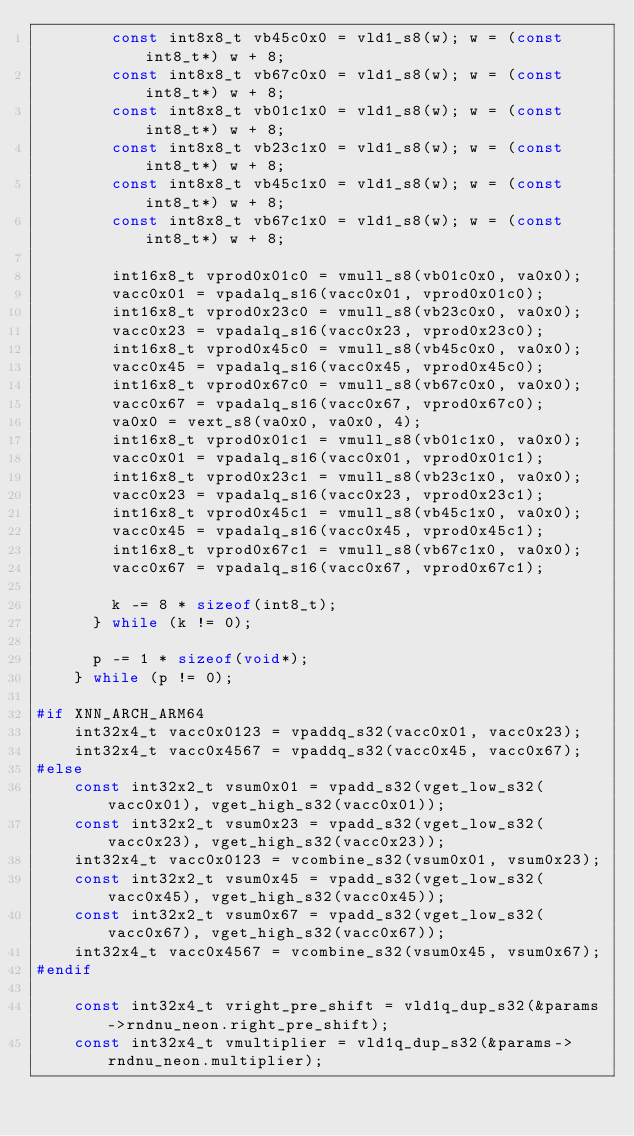<code> <loc_0><loc_0><loc_500><loc_500><_C_>        const int8x8_t vb45c0x0 = vld1_s8(w); w = (const int8_t*) w + 8;
        const int8x8_t vb67c0x0 = vld1_s8(w); w = (const int8_t*) w + 8;
        const int8x8_t vb01c1x0 = vld1_s8(w); w = (const int8_t*) w + 8;
        const int8x8_t vb23c1x0 = vld1_s8(w); w = (const int8_t*) w + 8;
        const int8x8_t vb45c1x0 = vld1_s8(w); w = (const int8_t*) w + 8;
        const int8x8_t vb67c1x0 = vld1_s8(w); w = (const int8_t*) w + 8;

        int16x8_t vprod0x01c0 = vmull_s8(vb01c0x0, va0x0);
        vacc0x01 = vpadalq_s16(vacc0x01, vprod0x01c0);
        int16x8_t vprod0x23c0 = vmull_s8(vb23c0x0, va0x0);
        vacc0x23 = vpadalq_s16(vacc0x23, vprod0x23c0);
        int16x8_t vprod0x45c0 = vmull_s8(vb45c0x0, va0x0);
        vacc0x45 = vpadalq_s16(vacc0x45, vprod0x45c0);
        int16x8_t vprod0x67c0 = vmull_s8(vb67c0x0, va0x0);
        vacc0x67 = vpadalq_s16(vacc0x67, vprod0x67c0);
        va0x0 = vext_s8(va0x0, va0x0, 4);
        int16x8_t vprod0x01c1 = vmull_s8(vb01c1x0, va0x0);
        vacc0x01 = vpadalq_s16(vacc0x01, vprod0x01c1);
        int16x8_t vprod0x23c1 = vmull_s8(vb23c1x0, va0x0);
        vacc0x23 = vpadalq_s16(vacc0x23, vprod0x23c1);
        int16x8_t vprod0x45c1 = vmull_s8(vb45c1x0, va0x0);
        vacc0x45 = vpadalq_s16(vacc0x45, vprod0x45c1);
        int16x8_t vprod0x67c1 = vmull_s8(vb67c1x0, va0x0);
        vacc0x67 = vpadalq_s16(vacc0x67, vprod0x67c1);

        k -= 8 * sizeof(int8_t);
      } while (k != 0);

      p -= 1 * sizeof(void*);
    } while (p != 0);

#if XNN_ARCH_ARM64
    int32x4_t vacc0x0123 = vpaddq_s32(vacc0x01, vacc0x23);
    int32x4_t vacc0x4567 = vpaddq_s32(vacc0x45, vacc0x67);
#else
    const int32x2_t vsum0x01 = vpadd_s32(vget_low_s32(vacc0x01), vget_high_s32(vacc0x01));
    const int32x2_t vsum0x23 = vpadd_s32(vget_low_s32(vacc0x23), vget_high_s32(vacc0x23));
    int32x4_t vacc0x0123 = vcombine_s32(vsum0x01, vsum0x23);
    const int32x2_t vsum0x45 = vpadd_s32(vget_low_s32(vacc0x45), vget_high_s32(vacc0x45));
    const int32x2_t vsum0x67 = vpadd_s32(vget_low_s32(vacc0x67), vget_high_s32(vacc0x67));
    int32x4_t vacc0x4567 = vcombine_s32(vsum0x45, vsum0x67);
#endif

    const int32x4_t vright_pre_shift = vld1q_dup_s32(&params->rndnu_neon.right_pre_shift);
    const int32x4_t vmultiplier = vld1q_dup_s32(&params->rndnu_neon.multiplier);</code> 